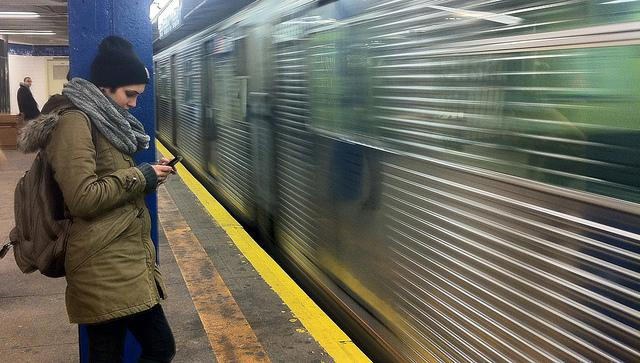What tells people where to stand for safety? yellow line 